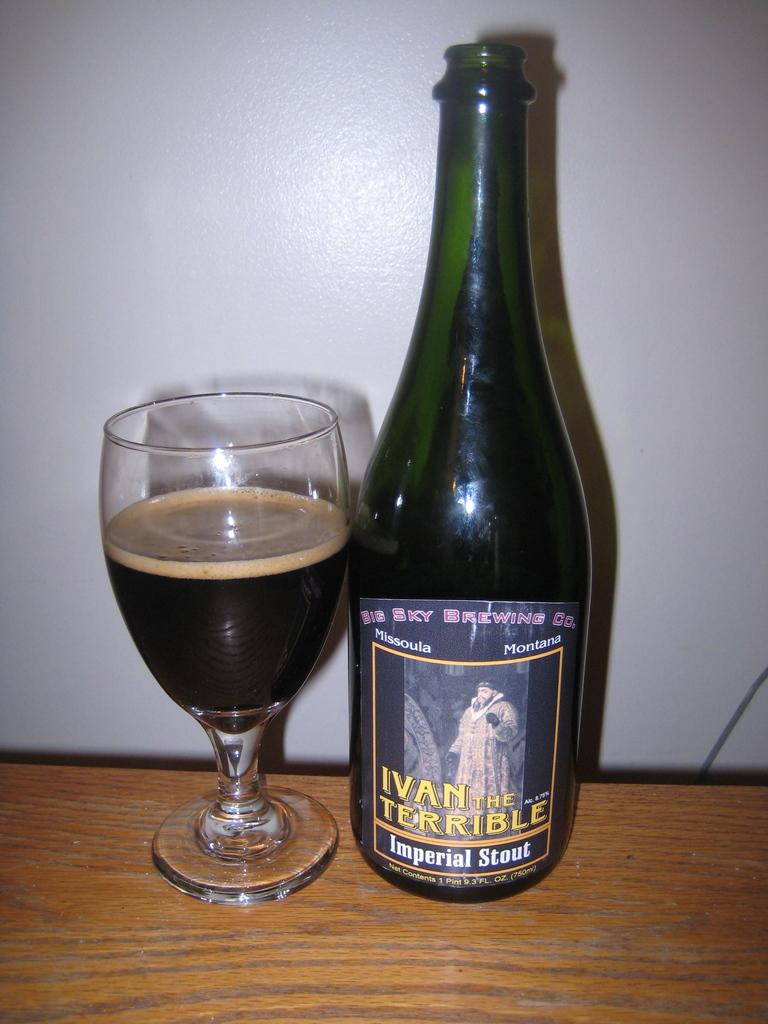<image>
Render a clear and concise summary of the photo. A bottle of Ivan the Terrible Imperial Stout. 